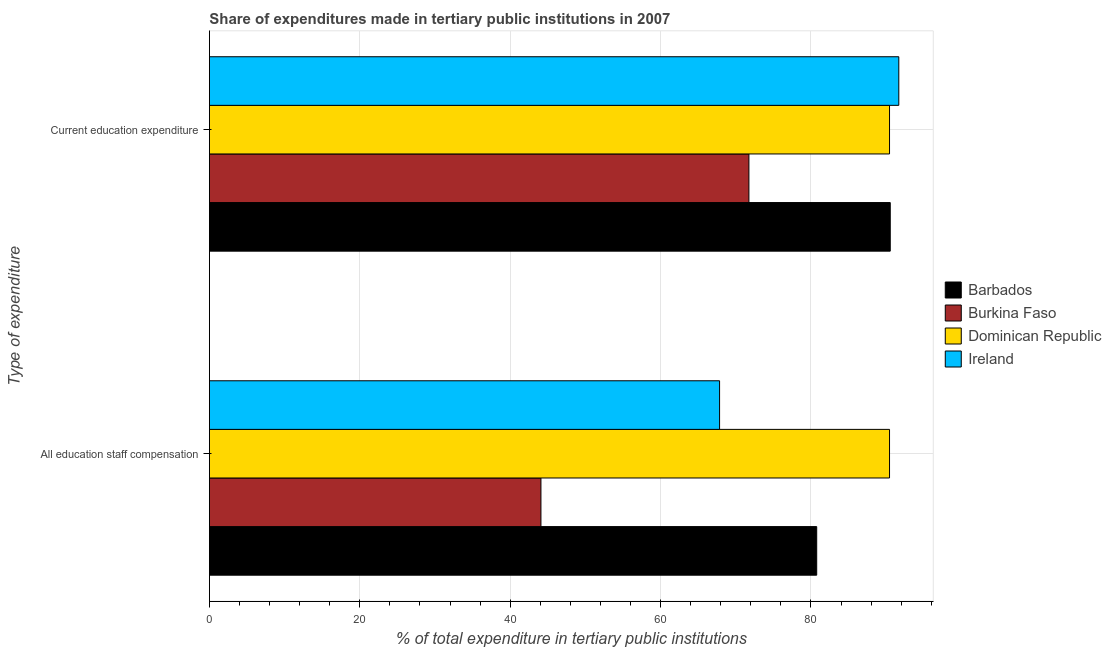How many different coloured bars are there?
Ensure brevity in your answer.  4. How many groups of bars are there?
Offer a terse response. 2. Are the number of bars on each tick of the Y-axis equal?
Your answer should be compact. Yes. How many bars are there on the 2nd tick from the top?
Make the answer very short. 4. How many bars are there on the 2nd tick from the bottom?
Make the answer very short. 4. What is the label of the 2nd group of bars from the top?
Ensure brevity in your answer.  All education staff compensation. What is the expenditure in staff compensation in Barbados?
Your answer should be compact. 80.77. Across all countries, what is the maximum expenditure in staff compensation?
Ensure brevity in your answer.  90.45. Across all countries, what is the minimum expenditure in staff compensation?
Provide a short and direct response. 44.09. In which country was the expenditure in education maximum?
Offer a very short reply. Ireland. In which country was the expenditure in staff compensation minimum?
Make the answer very short. Burkina Faso. What is the total expenditure in staff compensation in the graph?
Offer a terse response. 283.16. What is the difference between the expenditure in staff compensation in Dominican Republic and that in Burkina Faso?
Your response must be concise. 46.36. What is the difference between the expenditure in education in Dominican Republic and the expenditure in staff compensation in Barbados?
Offer a very short reply. 9.69. What is the average expenditure in education per country?
Ensure brevity in your answer.  86.11. What is the difference between the expenditure in staff compensation and expenditure in education in Dominican Republic?
Provide a short and direct response. 0. In how many countries, is the expenditure in staff compensation greater than 76 %?
Keep it short and to the point. 2. What is the ratio of the expenditure in education in Dominican Republic to that in Ireland?
Provide a short and direct response. 0.99. In how many countries, is the expenditure in staff compensation greater than the average expenditure in staff compensation taken over all countries?
Ensure brevity in your answer.  2. What does the 3rd bar from the top in Current education expenditure represents?
Your answer should be very brief. Burkina Faso. What does the 4th bar from the bottom in All education staff compensation represents?
Provide a short and direct response. Ireland. How many bars are there?
Make the answer very short. 8. What is the difference between two consecutive major ticks on the X-axis?
Ensure brevity in your answer.  20. Are the values on the major ticks of X-axis written in scientific E-notation?
Provide a short and direct response. No. How are the legend labels stacked?
Your response must be concise. Vertical. What is the title of the graph?
Provide a short and direct response. Share of expenditures made in tertiary public institutions in 2007. What is the label or title of the X-axis?
Give a very brief answer. % of total expenditure in tertiary public institutions. What is the label or title of the Y-axis?
Offer a very short reply. Type of expenditure. What is the % of total expenditure in tertiary public institutions of Barbados in All education staff compensation?
Offer a terse response. 80.77. What is the % of total expenditure in tertiary public institutions in Burkina Faso in All education staff compensation?
Your answer should be compact. 44.09. What is the % of total expenditure in tertiary public institutions of Dominican Republic in All education staff compensation?
Ensure brevity in your answer.  90.45. What is the % of total expenditure in tertiary public institutions of Ireland in All education staff compensation?
Give a very brief answer. 67.85. What is the % of total expenditure in tertiary public institutions in Barbados in Current education expenditure?
Keep it short and to the point. 90.55. What is the % of total expenditure in tertiary public institutions in Burkina Faso in Current education expenditure?
Give a very brief answer. 71.75. What is the % of total expenditure in tertiary public institutions in Dominican Republic in Current education expenditure?
Your answer should be compact. 90.45. What is the % of total expenditure in tertiary public institutions in Ireland in Current education expenditure?
Offer a terse response. 91.68. Across all Type of expenditure, what is the maximum % of total expenditure in tertiary public institutions of Barbados?
Keep it short and to the point. 90.55. Across all Type of expenditure, what is the maximum % of total expenditure in tertiary public institutions in Burkina Faso?
Offer a terse response. 71.75. Across all Type of expenditure, what is the maximum % of total expenditure in tertiary public institutions of Dominican Republic?
Give a very brief answer. 90.45. Across all Type of expenditure, what is the maximum % of total expenditure in tertiary public institutions in Ireland?
Your response must be concise. 91.68. Across all Type of expenditure, what is the minimum % of total expenditure in tertiary public institutions in Barbados?
Your answer should be compact. 80.77. Across all Type of expenditure, what is the minimum % of total expenditure in tertiary public institutions of Burkina Faso?
Offer a terse response. 44.09. Across all Type of expenditure, what is the minimum % of total expenditure in tertiary public institutions in Dominican Republic?
Offer a terse response. 90.45. Across all Type of expenditure, what is the minimum % of total expenditure in tertiary public institutions of Ireland?
Offer a very short reply. 67.85. What is the total % of total expenditure in tertiary public institutions of Barbados in the graph?
Keep it short and to the point. 171.32. What is the total % of total expenditure in tertiary public institutions of Burkina Faso in the graph?
Offer a terse response. 115.84. What is the total % of total expenditure in tertiary public institutions of Dominican Republic in the graph?
Make the answer very short. 180.91. What is the total % of total expenditure in tertiary public institutions in Ireland in the graph?
Offer a very short reply. 159.53. What is the difference between the % of total expenditure in tertiary public institutions of Barbados in All education staff compensation and that in Current education expenditure?
Keep it short and to the point. -9.78. What is the difference between the % of total expenditure in tertiary public institutions of Burkina Faso in All education staff compensation and that in Current education expenditure?
Provide a succinct answer. -27.66. What is the difference between the % of total expenditure in tertiary public institutions in Ireland in All education staff compensation and that in Current education expenditure?
Offer a terse response. -23.84. What is the difference between the % of total expenditure in tertiary public institutions in Barbados in All education staff compensation and the % of total expenditure in tertiary public institutions in Burkina Faso in Current education expenditure?
Provide a succinct answer. 9.02. What is the difference between the % of total expenditure in tertiary public institutions in Barbados in All education staff compensation and the % of total expenditure in tertiary public institutions in Dominican Republic in Current education expenditure?
Your answer should be very brief. -9.69. What is the difference between the % of total expenditure in tertiary public institutions of Barbados in All education staff compensation and the % of total expenditure in tertiary public institutions of Ireland in Current education expenditure?
Ensure brevity in your answer.  -10.92. What is the difference between the % of total expenditure in tertiary public institutions in Burkina Faso in All education staff compensation and the % of total expenditure in tertiary public institutions in Dominican Republic in Current education expenditure?
Provide a succinct answer. -46.36. What is the difference between the % of total expenditure in tertiary public institutions in Burkina Faso in All education staff compensation and the % of total expenditure in tertiary public institutions in Ireland in Current education expenditure?
Provide a succinct answer. -47.59. What is the difference between the % of total expenditure in tertiary public institutions in Dominican Republic in All education staff compensation and the % of total expenditure in tertiary public institutions in Ireland in Current education expenditure?
Your response must be concise. -1.23. What is the average % of total expenditure in tertiary public institutions in Barbados per Type of expenditure?
Provide a short and direct response. 85.66. What is the average % of total expenditure in tertiary public institutions of Burkina Faso per Type of expenditure?
Offer a very short reply. 57.92. What is the average % of total expenditure in tertiary public institutions of Dominican Republic per Type of expenditure?
Make the answer very short. 90.45. What is the average % of total expenditure in tertiary public institutions of Ireland per Type of expenditure?
Your response must be concise. 79.77. What is the difference between the % of total expenditure in tertiary public institutions in Barbados and % of total expenditure in tertiary public institutions in Burkina Faso in All education staff compensation?
Offer a terse response. 36.68. What is the difference between the % of total expenditure in tertiary public institutions of Barbados and % of total expenditure in tertiary public institutions of Dominican Republic in All education staff compensation?
Make the answer very short. -9.69. What is the difference between the % of total expenditure in tertiary public institutions in Barbados and % of total expenditure in tertiary public institutions in Ireland in All education staff compensation?
Offer a terse response. 12.92. What is the difference between the % of total expenditure in tertiary public institutions of Burkina Faso and % of total expenditure in tertiary public institutions of Dominican Republic in All education staff compensation?
Ensure brevity in your answer.  -46.36. What is the difference between the % of total expenditure in tertiary public institutions of Burkina Faso and % of total expenditure in tertiary public institutions of Ireland in All education staff compensation?
Provide a short and direct response. -23.76. What is the difference between the % of total expenditure in tertiary public institutions of Dominican Republic and % of total expenditure in tertiary public institutions of Ireland in All education staff compensation?
Your answer should be compact. 22.6. What is the difference between the % of total expenditure in tertiary public institutions of Barbados and % of total expenditure in tertiary public institutions of Burkina Faso in Current education expenditure?
Your answer should be compact. 18.8. What is the difference between the % of total expenditure in tertiary public institutions in Barbados and % of total expenditure in tertiary public institutions in Dominican Republic in Current education expenditure?
Offer a terse response. 0.09. What is the difference between the % of total expenditure in tertiary public institutions in Barbados and % of total expenditure in tertiary public institutions in Ireland in Current education expenditure?
Provide a short and direct response. -1.14. What is the difference between the % of total expenditure in tertiary public institutions of Burkina Faso and % of total expenditure in tertiary public institutions of Dominican Republic in Current education expenditure?
Your answer should be very brief. -18.7. What is the difference between the % of total expenditure in tertiary public institutions of Burkina Faso and % of total expenditure in tertiary public institutions of Ireland in Current education expenditure?
Offer a very short reply. -19.93. What is the difference between the % of total expenditure in tertiary public institutions in Dominican Republic and % of total expenditure in tertiary public institutions in Ireland in Current education expenditure?
Your response must be concise. -1.23. What is the ratio of the % of total expenditure in tertiary public institutions in Barbados in All education staff compensation to that in Current education expenditure?
Provide a succinct answer. 0.89. What is the ratio of the % of total expenditure in tertiary public institutions in Burkina Faso in All education staff compensation to that in Current education expenditure?
Give a very brief answer. 0.61. What is the ratio of the % of total expenditure in tertiary public institutions in Dominican Republic in All education staff compensation to that in Current education expenditure?
Ensure brevity in your answer.  1. What is the ratio of the % of total expenditure in tertiary public institutions in Ireland in All education staff compensation to that in Current education expenditure?
Provide a succinct answer. 0.74. What is the difference between the highest and the second highest % of total expenditure in tertiary public institutions in Barbados?
Provide a short and direct response. 9.78. What is the difference between the highest and the second highest % of total expenditure in tertiary public institutions of Burkina Faso?
Offer a terse response. 27.66. What is the difference between the highest and the second highest % of total expenditure in tertiary public institutions of Ireland?
Provide a short and direct response. 23.84. What is the difference between the highest and the lowest % of total expenditure in tertiary public institutions in Barbados?
Keep it short and to the point. 9.78. What is the difference between the highest and the lowest % of total expenditure in tertiary public institutions in Burkina Faso?
Your answer should be compact. 27.66. What is the difference between the highest and the lowest % of total expenditure in tertiary public institutions of Ireland?
Give a very brief answer. 23.84. 